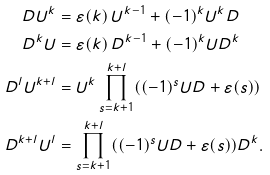<formula> <loc_0><loc_0><loc_500><loc_500>D U ^ { k } & = \varepsilon ( k ) \, U ^ { k - 1 } + ( - 1 ) ^ { k } U ^ { k } D \\ D ^ { k } U & = \varepsilon ( k ) \, D ^ { k - 1 } + ( - 1 ) ^ { k } U D ^ { k } \\ D ^ { l } U ^ { k + l } & = U ^ { k } \prod _ { s = k + 1 } ^ { k + l } ( ( - 1 ) ^ { s } U D + \varepsilon ( s ) ) \\ D ^ { k + l } U ^ { l } & = \prod _ { s = k + 1 } ^ { k + l } ( ( - 1 ) ^ { s } U D + \varepsilon ( s ) ) D ^ { k } .</formula> 